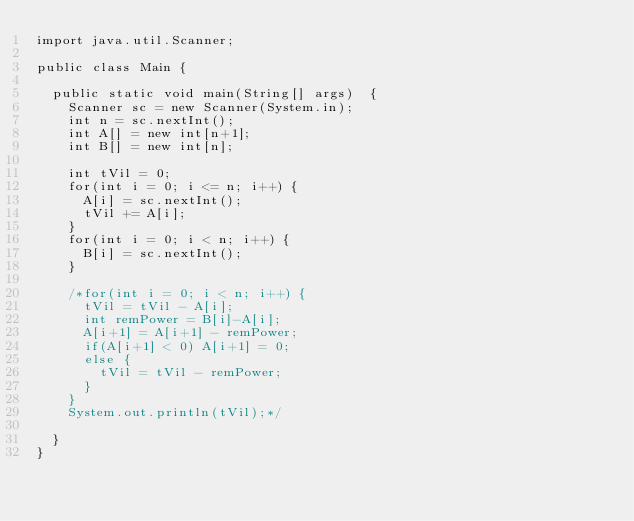Convert code to text. <code><loc_0><loc_0><loc_500><loc_500><_Java_>import java.util.Scanner;
 
public class Main {
  
  public static void main(String[] args)  {
    Scanner sc = new Scanner(System.in);
    int n = sc.nextInt();
    int A[] = new int[n+1];
    int B[] = new int[n];
    
    int tVil = 0;
    for(int i = 0; i <= n; i++) {
      A[i] = sc.nextInt();
      tVil += A[i];
    }
    for(int i = 0; i < n; i++) {
      B[i] = sc.nextInt();
    }
    
    /*for(int i = 0; i < n; i++) {
      tVil = tVil - A[i];
      int remPower = B[i]-A[i];
      A[i+1] = A[i+1] - remPower;
      if(A[i+1] < 0) A[i+1] = 0;
      else {
        tVil = tVil - remPower;
      }
    }
    System.out.println(tVil);*/
    
  }
}</code> 